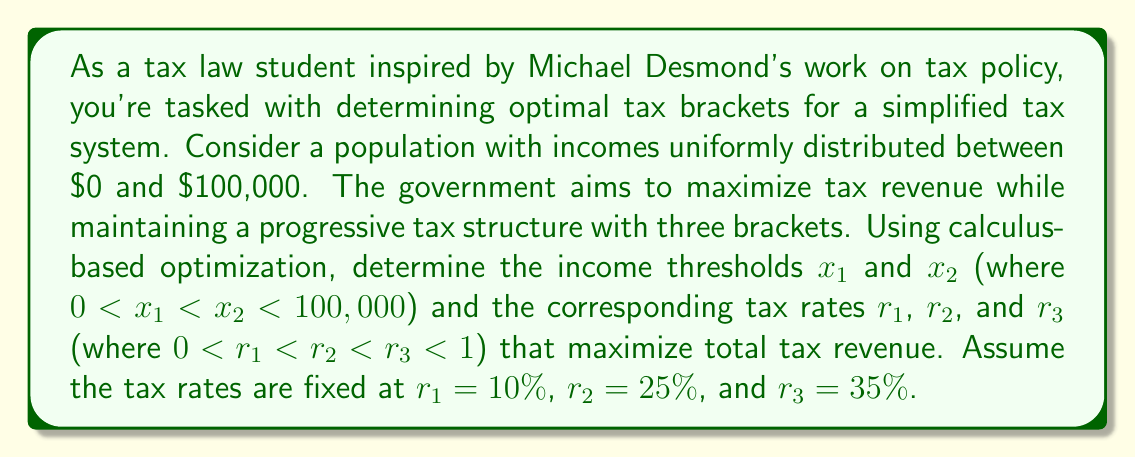Can you solve this math problem? To solve this problem, we'll use calculus-based optimization techniques:

1) First, let's define the tax revenue function. Given the uniform distribution of incomes, the probability density function is constant: $f(x) = \frac{1}{100,000}$ for $0 \leq x \leq 100,000$.

2) The tax revenue function $R(x_1, x_2)$ can be written as:

   $$R(x_1, x_2) = \int_0^{x_1} 0.1x \cdot \frac{1}{100,000}dx + \int_{x_1}^{x_2} (0.1x_1 + 0.25(x-x_1)) \cdot \frac{1}{100,000}dx + \int_{x_2}^{100,000} (0.1x_1 + 0.25(x_2-x_1) + 0.35(x-x_2)) \cdot \frac{1}{100,000}dx$$

3) Simplify and compute the integrals:

   $$R(x_1, x_2) = \frac{1}{200,000}[0.1x_1^2 + 0.25(x_2^2 - x_1^2) + 0.35(100,000^2 - x_2^2)] + \frac{1}{100,000}[0.1x_1(100,000 - x_1) + 0.25x_2(x_2 - x_1)]$$

4) To find the maximum, we need to find the partial derivatives and set them to zero:

   $$\frac{\partial R}{\partial x_1} = \frac{1}{100,000}[-0.3x_1 + 0.1 \cdot 100,000 - 0.25x_2] = 0$$
   $$\frac{\partial R}{\partial x_2} = \frac{1}{100,000}[-0.2x_2 + 0.25x_1 + 0.35 \cdot 100,000] = 0$$

5) Solve this system of equations:

   From the first equation: $x_1 = \frac{10,000 - 0.25x_2}{0.3}$
   Substitute this into the second equation:
   $$-0.2x_2 + 0.25(\frac{10,000 - 0.25x_2}{0.3}) + 35,000 = 0$$

6) Solve for $x_2$:

   $$x_2 = 58,333.33$$

7) Substitute back to find $x_1$:

   $$x_1 = \frac{10,000 - 0.25 \cdot 58,333.33}{0.3} = 18,055.56$$

8) Round to the nearest whole dollar for practical application:

   $x_1 = 18,056$ and $x_2 = 58,333$

These values represent the optimal income thresholds for the three tax brackets that maximize tax revenue under the given constraints.
Answer: $x_1 = \$18,056, x_2 = \$58,333$ 